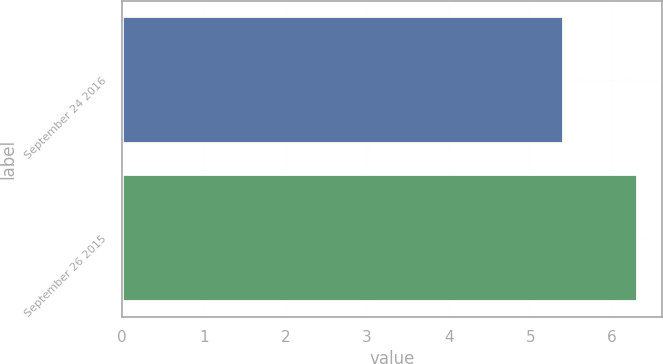<chart> <loc_0><loc_0><loc_500><loc_500><bar_chart><fcel>September 24 2016<fcel>September 26 2015<nl><fcel>5.4<fcel>6.3<nl></chart> 